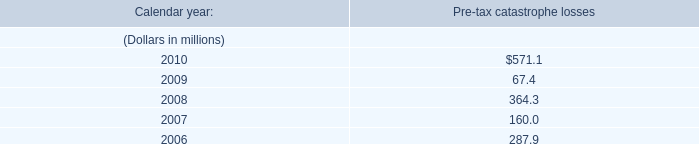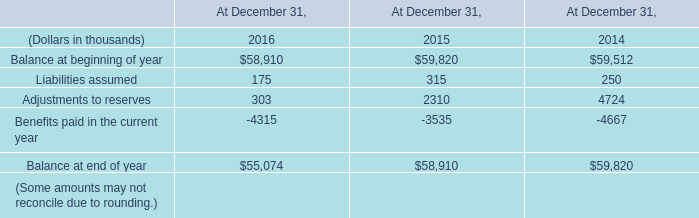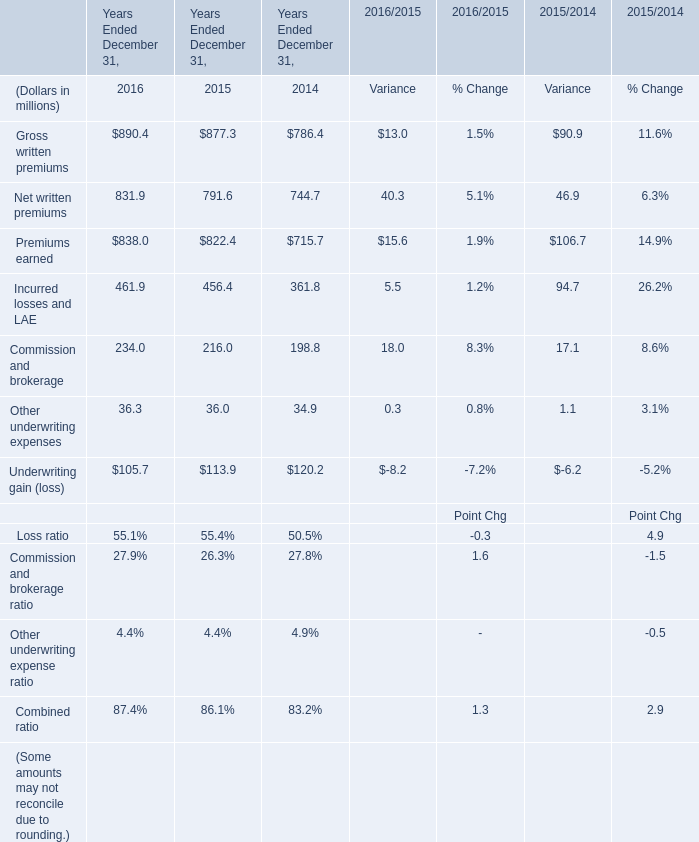Which year is Incurred losses and LAE the highest? 
Answer: 2016. 